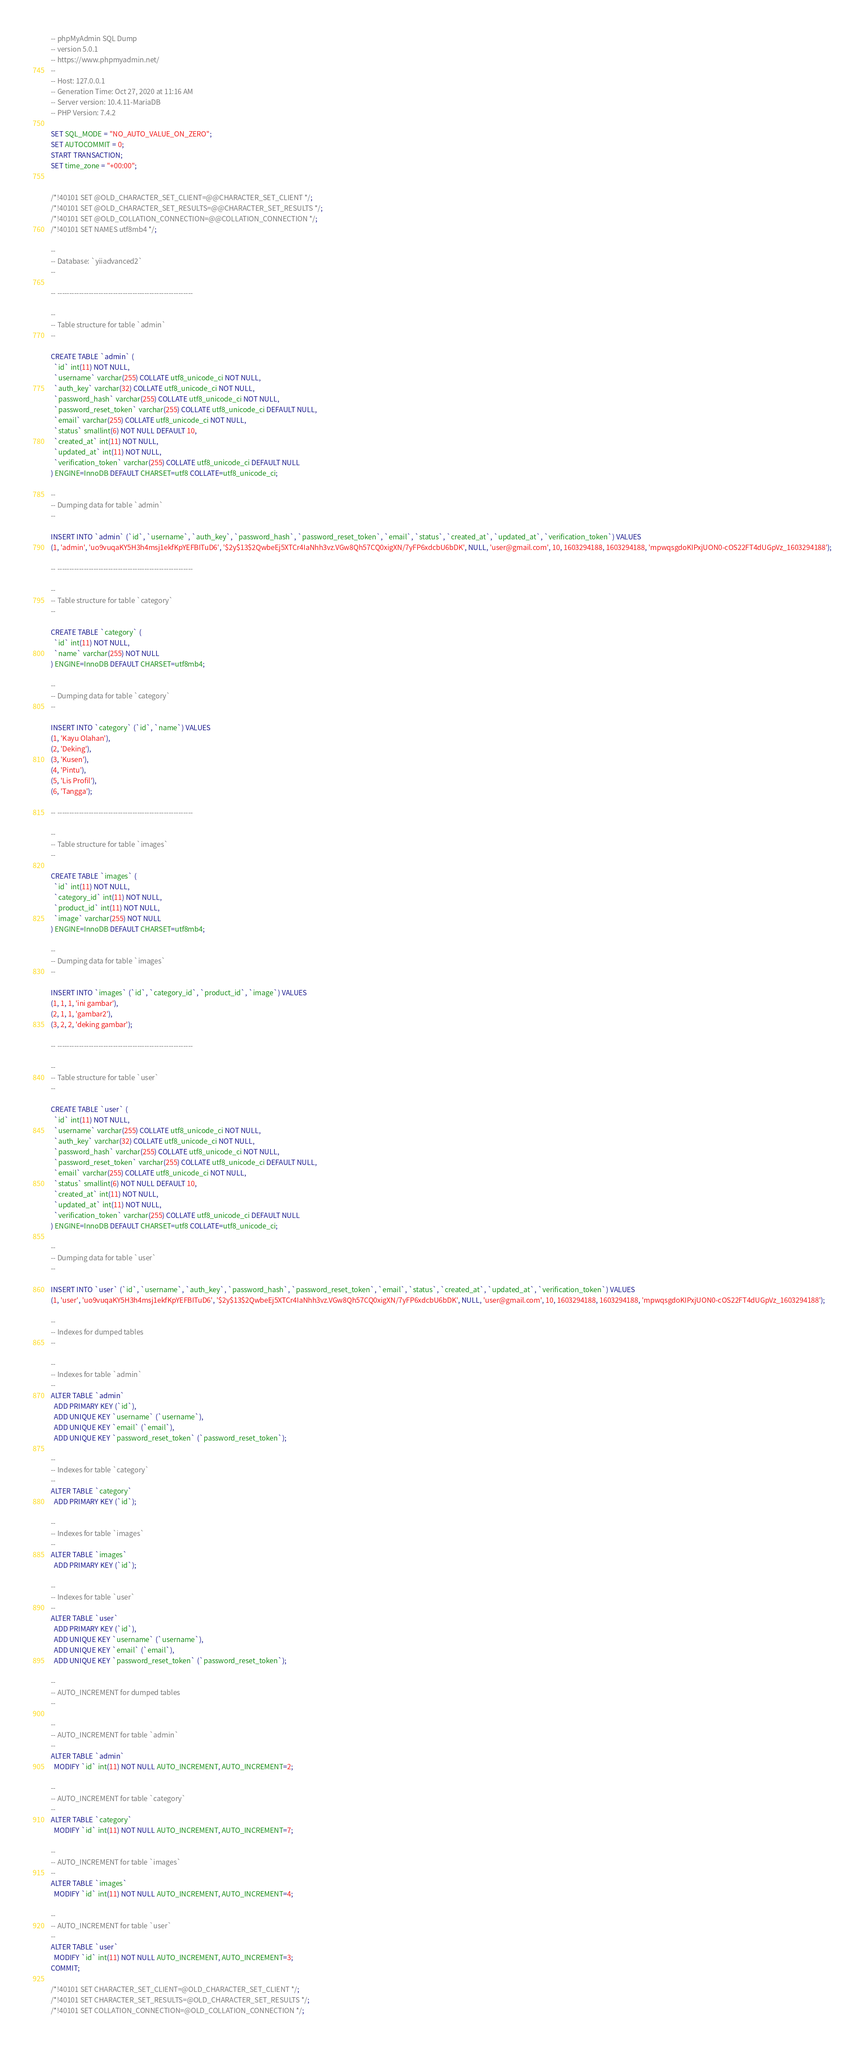Convert code to text. <code><loc_0><loc_0><loc_500><loc_500><_SQL_>-- phpMyAdmin SQL Dump
-- version 5.0.1
-- https://www.phpmyadmin.net/
--
-- Host: 127.0.0.1
-- Generation Time: Oct 27, 2020 at 11:16 AM
-- Server version: 10.4.11-MariaDB
-- PHP Version: 7.4.2

SET SQL_MODE = "NO_AUTO_VALUE_ON_ZERO";
SET AUTOCOMMIT = 0;
START TRANSACTION;
SET time_zone = "+00:00";


/*!40101 SET @OLD_CHARACTER_SET_CLIENT=@@CHARACTER_SET_CLIENT */;
/*!40101 SET @OLD_CHARACTER_SET_RESULTS=@@CHARACTER_SET_RESULTS */;
/*!40101 SET @OLD_COLLATION_CONNECTION=@@COLLATION_CONNECTION */;
/*!40101 SET NAMES utf8mb4 */;

--
-- Database: `yiiadvanced2`
--

-- --------------------------------------------------------

--
-- Table structure for table `admin`
--

CREATE TABLE `admin` (
  `id` int(11) NOT NULL,
  `username` varchar(255) COLLATE utf8_unicode_ci NOT NULL,
  `auth_key` varchar(32) COLLATE utf8_unicode_ci NOT NULL,
  `password_hash` varchar(255) COLLATE utf8_unicode_ci NOT NULL,
  `password_reset_token` varchar(255) COLLATE utf8_unicode_ci DEFAULT NULL,
  `email` varchar(255) COLLATE utf8_unicode_ci NOT NULL,
  `status` smallint(6) NOT NULL DEFAULT 10,
  `created_at` int(11) NOT NULL,
  `updated_at` int(11) NOT NULL,
  `verification_token` varchar(255) COLLATE utf8_unicode_ci DEFAULT NULL
) ENGINE=InnoDB DEFAULT CHARSET=utf8 COLLATE=utf8_unicode_ci;

--
-- Dumping data for table `admin`
--

INSERT INTO `admin` (`id`, `username`, `auth_key`, `password_hash`, `password_reset_token`, `email`, `status`, `created_at`, `updated_at`, `verification_token`) VALUES
(1, 'admin', 'uo9vuqaKY5H3h4msj1ekfKpYEFBITuD6', '$2y$13$2QwbeEj5XTCr4IaNhh3vz.VGw8Qh57CQ0xigXN/7yFP6xdcbU6bDK', NULL, 'user@gmail.com', 10, 1603294188, 1603294188, 'mpwqsgdoKIPxjUON0-cOS22FT4dUGpVz_1603294188');

-- --------------------------------------------------------

--
-- Table structure for table `category`
--

CREATE TABLE `category` (
  `id` int(11) NOT NULL,
  `name` varchar(255) NOT NULL
) ENGINE=InnoDB DEFAULT CHARSET=utf8mb4;

--
-- Dumping data for table `category`
--

INSERT INTO `category` (`id`, `name`) VALUES
(1, 'Kayu Olahan'),
(2, 'Deking'),
(3, 'Kusen'),
(4, 'Pintu'),
(5, 'Lis Profil'),
(6, 'Tangga');

-- --------------------------------------------------------

--
-- Table structure for table `images`
--

CREATE TABLE `images` (
  `id` int(11) NOT NULL,
  `category_id` int(11) NOT NULL,
  `product_id` int(11) NOT NULL,
  `image` varchar(255) NOT NULL
) ENGINE=InnoDB DEFAULT CHARSET=utf8mb4;

--
-- Dumping data for table `images`
--

INSERT INTO `images` (`id`, `category_id`, `product_id`, `image`) VALUES
(1, 1, 1, 'ini gambar'),
(2, 1, 1, 'gambar2'),
(3, 2, 2, 'deking gambar');

-- --------------------------------------------------------

--
-- Table structure for table `user`
--

CREATE TABLE `user` (
  `id` int(11) NOT NULL,
  `username` varchar(255) COLLATE utf8_unicode_ci NOT NULL,
  `auth_key` varchar(32) COLLATE utf8_unicode_ci NOT NULL,
  `password_hash` varchar(255) COLLATE utf8_unicode_ci NOT NULL,
  `password_reset_token` varchar(255) COLLATE utf8_unicode_ci DEFAULT NULL,
  `email` varchar(255) COLLATE utf8_unicode_ci NOT NULL,
  `status` smallint(6) NOT NULL DEFAULT 10,
  `created_at` int(11) NOT NULL,
  `updated_at` int(11) NOT NULL,
  `verification_token` varchar(255) COLLATE utf8_unicode_ci DEFAULT NULL
) ENGINE=InnoDB DEFAULT CHARSET=utf8 COLLATE=utf8_unicode_ci;

--
-- Dumping data for table `user`
--

INSERT INTO `user` (`id`, `username`, `auth_key`, `password_hash`, `password_reset_token`, `email`, `status`, `created_at`, `updated_at`, `verification_token`) VALUES
(1, 'user', 'uo9vuqaKY5H3h4msj1ekfKpYEFBITuD6', '$2y$13$2QwbeEj5XTCr4IaNhh3vz.VGw8Qh57CQ0xigXN/7yFP6xdcbU6bDK', NULL, 'user@gmail.com', 10, 1603294188, 1603294188, 'mpwqsgdoKIPxjUON0-cOS22FT4dUGpVz_1603294188');

--
-- Indexes for dumped tables
--

--
-- Indexes for table `admin`
--
ALTER TABLE `admin`
  ADD PRIMARY KEY (`id`),
  ADD UNIQUE KEY `username` (`username`),
  ADD UNIQUE KEY `email` (`email`),
  ADD UNIQUE KEY `password_reset_token` (`password_reset_token`);

--
-- Indexes for table `category`
--
ALTER TABLE `category`
  ADD PRIMARY KEY (`id`);

--
-- Indexes for table `images`
--
ALTER TABLE `images`
  ADD PRIMARY KEY (`id`);

--
-- Indexes for table `user`
--
ALTER TABLE `user`
  ADD PRIMARY KEY (`id`),
  ADD UNIQUE KEY `username` (`username`),
  ADD UNIQUE KEY `email` (`email`),
  ADD UNIQUE KEY `password_reset_token` (`password_reset_token`);

--
-- AUTO_INCREMENT for dumped tables
--

--
-- AUTO_INCREMENT for table `admin`
--
ALTER TABLE `admin`
  MODIFY `id` int(11) NOT NULL AUTO_INCREMENT, AUTO_INCREMENT=2;

--
-- AUTO_INCREMENT for table `category`
--
ALTER TABLE `category`
  MODIFY `id` int(11) NOT NULL AUTO_INCREMENT, AUTO_INCREMENT=7;

--
-- AUTO_INCREMENT for table `images`
--
ALTER TABLE `images`
  MODIFY `id` int(11) NOT NULL AUTO_INCREMENT, AUTO_INCREMENT=4;

--
-- AUTO_INCREMENT for table `user`
--
ALTER TABLE `user`
  MODIFY `id` int(11) NOT NULL AUTO_INCREMENT, AUTO_INCREMENT=3;
COMMIT;

/*!40101 SET CHARACTER_SET_CLIENT=@OLD_CHARACTER_SET_CLIENT */;
/*!40101 SET CHARACTER_SET_RESULTS=@OLD_CHARACTER_SET_RESULTS */;
/*!40101 SET COLLATION_CONNECTION=@OLD_COLLATION_CONNECTION */;
</code> 